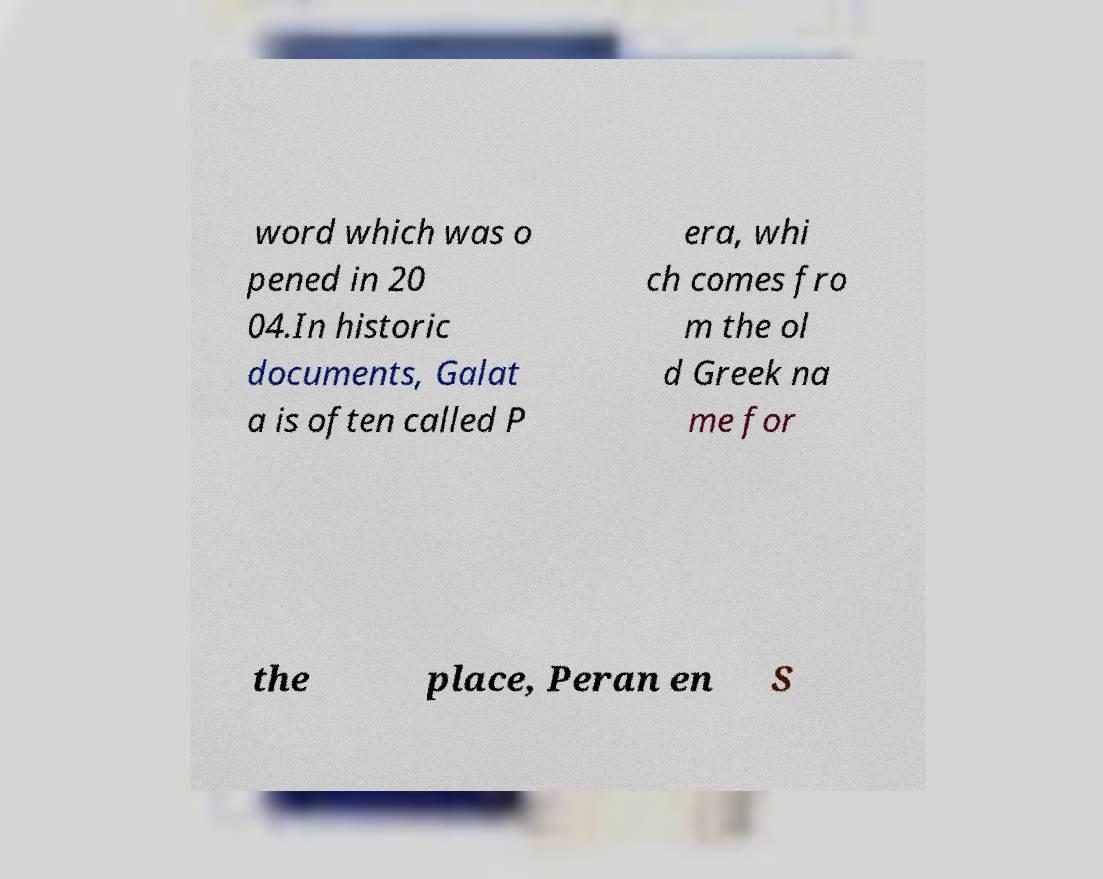Can you read and provide the text displayed in the image?This photo seems to have some interesting text. Can you extract and type it out for me? word which was o pened in 20 04.In historic documents, Galat a is often called P era, whi ch comes fro m the ol d Greek na me for the place, Peran en S 